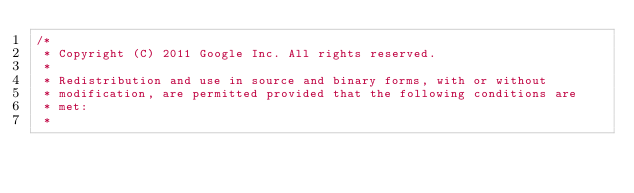<code> <loc_0><loc_0><loc_500><loc_500><_C++_>/*
 * Copyright (C) 2011 Google Inc. All rights reserved.
 *
 * Redistribution and use in source and binary forms, with or without
 * modification, are permitted provided that the following conditions are
 * met:
 *</code> 